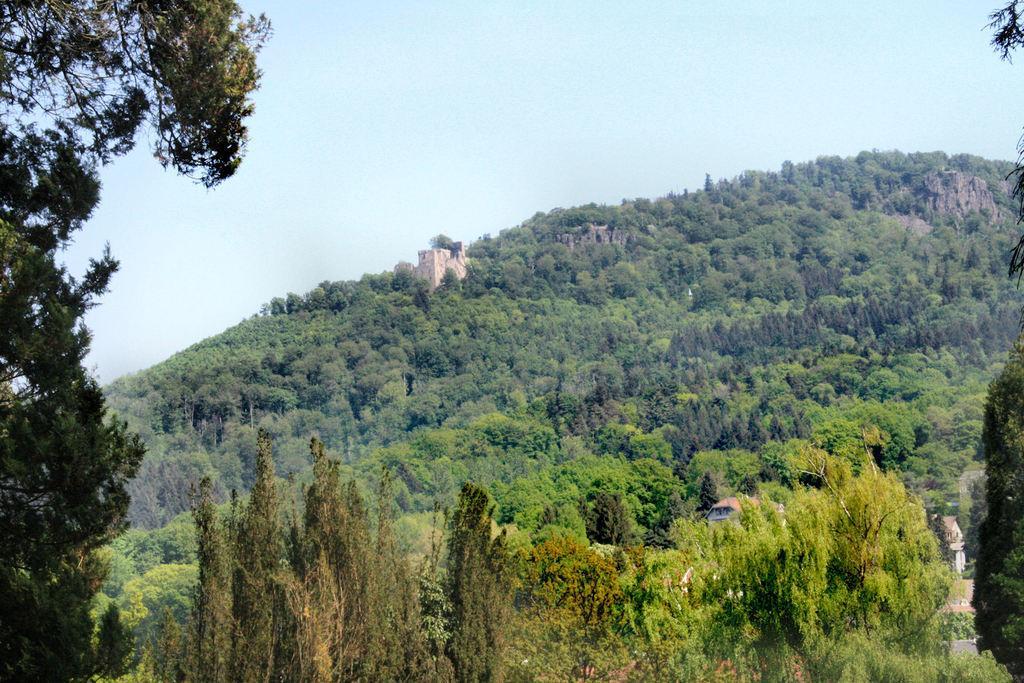Can you describe this image briefly? In this picture I can see trees and few buildings and I can see a blue sky. 